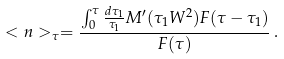Convert formula to latex. <formula><loc_0><loc_0><loc_500><loc_500>< n > _ { \tau } = \frac { \int _ { 0 } ^ { \tau } \frac { d \tau _ { 1 } } { \tau _ { 1 } } M ^ { \prime } ( \tau _ { 1 } W ^ { 2 } ) F ( \tau - \tau _ { 1 } ) } { F ( \tau ) } \, .</formula> 